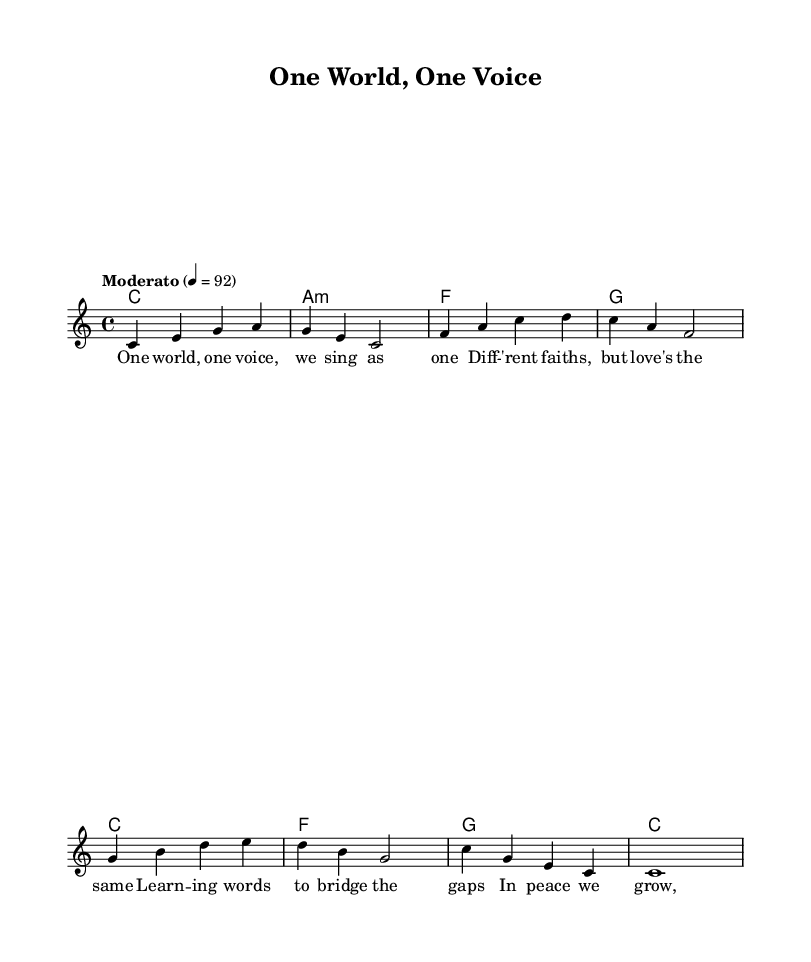What is the key signature of this music? The key signature is C major, which has no sharps or flats indicated at the beginning of the staff.
Answer: C major What is the time signature of this music? The time signature is indicated as 4/4, which means there are four beats in each measure.
Answer: 4/4 What is the tempo marking given? The tempo marking indicates "Moderato," suggesting a moderate pace, specifically set to 92 beats per minute (quarter note).
Answer: Moderato How many measures are in the melody section? By counting the measures in the provided melody line, we see there are a total of eight measures.
Answer: Eight Which chord follows the C major chord in the harmonies? The chord that follows the C major chord in the sequence provided is A minor, which is the second chord in the harmony line.
Answer: A minor What is the message conveyed in the lyrics of this piece? The lyrics emphasize unity and the idea of different faiths coming together through love and learning, illustrating a message of peace and growth.
Answer: Unity How many distinct notes are in the first line of the melody? The first line of the melody includes five distinct notes: C, E, G, A, and F, which can be counted directly from the notation.
Answer: Five 